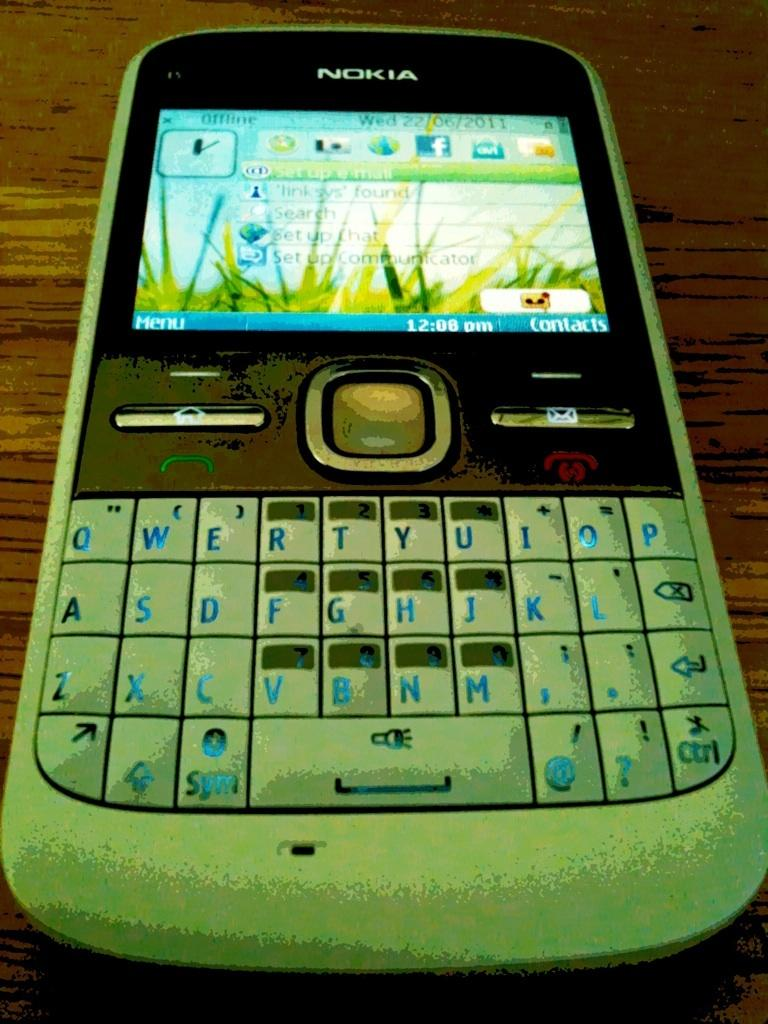<image>
Describe the image concisely. a Nokia phone with a Facebook icon on it 